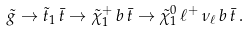Convert formula to latex. <formula><loc_0><loc_0><loc_500><loc_500>\tilde { g } \to \tilde { t } _ { 1 } \, \bar { t } \to \tilde { \chi } ^ { + } _ { 1 } \, b \, \bar { t } \to \tilde { \chi } ^ { 0 } _ { 1 } \, \ell ^ { + } \, \nu _ { \ell } \, b \, \bar { t } \, .</formula> 